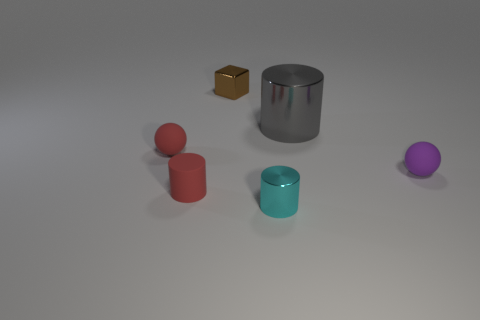Subtract all tiny cylinders. How many cylinders are left? 1 Add 2 tiny balls. How many objects exist? 8 Subtract all blocks. How many objects are left? 5 Subtract all cyan cylinders. How many cylinders are left? 2 Subtract all red cylinders. How many red spheres are left? 1 Subtract all big blue metal objects. Subtract all gray cylinders. How many objects are left? 5 Add 4 small brown things. How many small brown things are left? 5 Add 4 tiny red cubes. How many tiny red cubes exist? 4 Subtract 1 cyan cylinders. How many objects are left? 5 Subtract 2 spheres. How many spheres are left? 0 